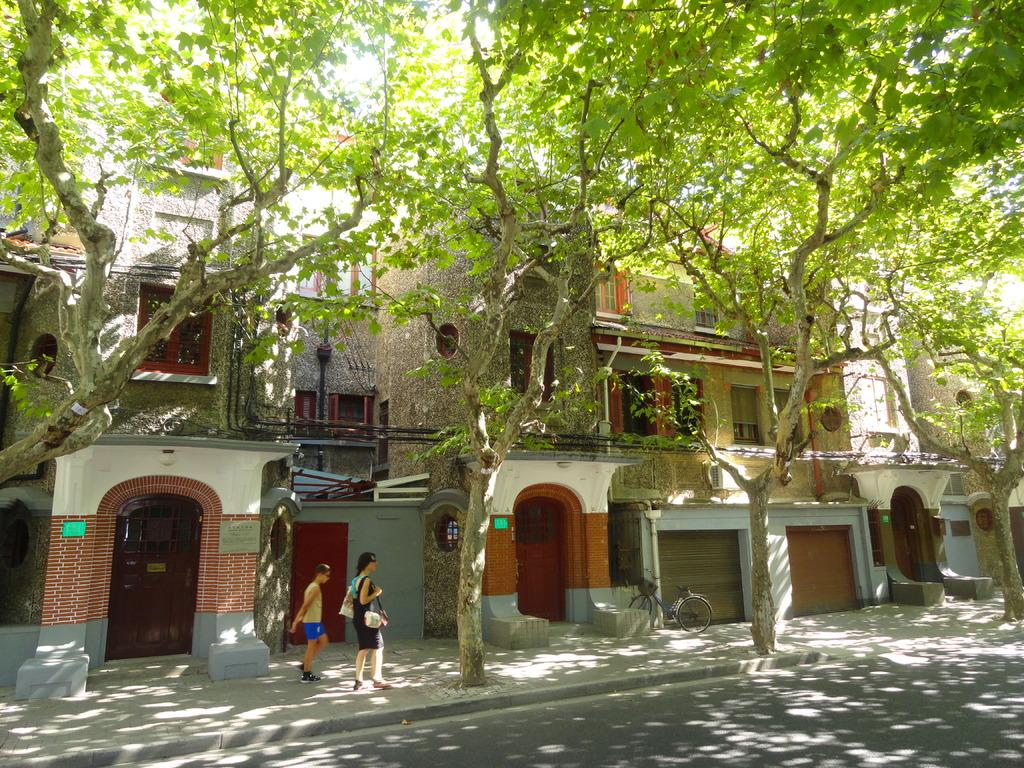What type of structures can be seen in the image? There are buildings with windows in the image. What is the path used for in the image? The path is likely used for walking or transportation in the image. Can you describe the people visible in the image? There are people visible in the image, but their specific actions or characteristics are not mentioned in the provided facts. What mode of transportation is present in the image? There is a bicycle in the image. What type of vegetation is present in the image? There are trees in the image. What type of surface is visible in the image? There is a road in the image. What type of art is displayed on the tongue of the person in the image? There is no mention of a tongue or any art in the image; it features buildings, a path, people, a bicycle, trees, and a road. 